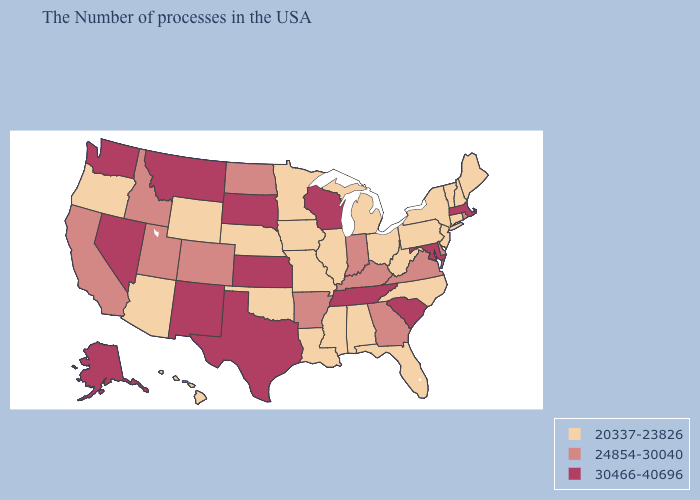Does the first symbol in the legend represent the smallest category?
Short answer required. Yes. What is the value of Maine?
Keep it brief. 20337-23826. Which states hav the highest value in the Northeast?
Keep it brief. Massachusetts. What is the lowest value in the MidWest?
Give a very brief answer. 20337-23826. Which states have the lowest value in the West?
Quick response, please. Wyoming, Arizona, Oregon, Hawaii. Among the states that border North Dakota , does Minnesota have the highest value?
Keep it brief. No. Does the map have missing data?
Quick response, please. No. What is the value of Hawaii?
Answer briefly. 20337-23826. Name the states that have a value in the range 30466-40696?
Keep it brief. Massachusetts, Maryland, South Carolina, Tennessee, Wisconsin, Kansas, Texas, South Dakota, New Mexico, Montana, Nevada, Washington, Alaska. What is the highest value in the USA?
Be succinct. 30466-40696. Among the states that border Michigan , which have the lowest value?
Concise answer only. Ohio. Which states hav the highest value in the MidWest?
Be succinct. Wisconsin, Kansas, South Dakota. Does Minnesota have a higher value than New Mexico?
Answer briefly. No. Name the states that have a value in the range 30466-40696?
Keep it brief. Massachusetts, Maryland, South Carolina, Tennessee, Wisconsin, Kansas, Texas, South Dakota, New Mexico, Montana, Nevada, Washington, Alaska. What is the highest value in the USA?
Short answer required. 30466-40696. 